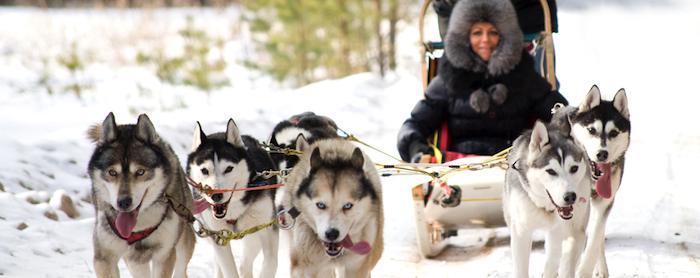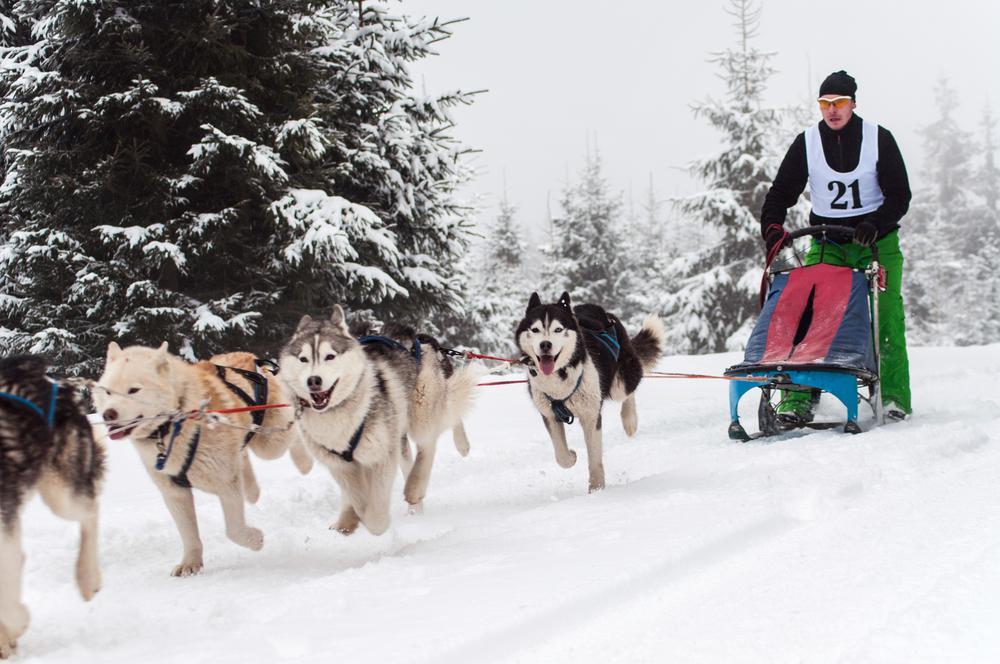The first image is the image on the left, the second image is the image on the right. For the images displayed, is the sentence "The dog sled team on the right heads diagonally to the left, and the dog team on the left heads toward the camera." factually correct? Answer yes or no. Yes. 